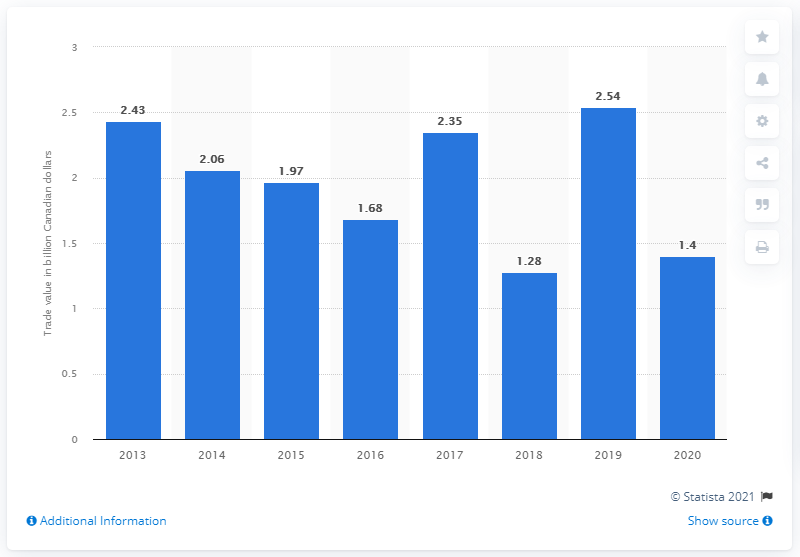Highlight a few significant elements in this photo. In 2010, the value of imports from Saudi Arabia to Canada was 2.54 billion dollars. The value of imports from Saudi Arabia to Canada in 2020 was CAD 1.4 billion. 